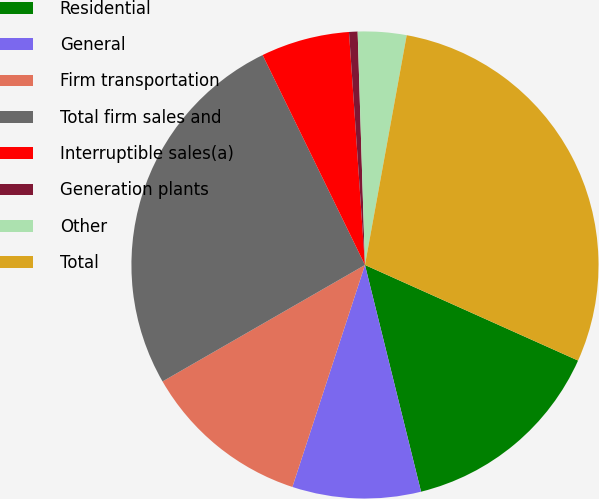Convert chart. <chart><loc_0><loc_0><loc_500><loc_500><pie_chart><fcel>Residential<fcel>General<fcel>Firm transportation<fcel>Total firm sales and<fcel>Interruptible sales(a)<fcel>Generation plants<fcel>Other<fcel>Total<nl><fcel>14.43%<fcel>8.89%<fcel>11.66%<fcel>26.09%<fcel>6.13%<fcel>0.59%<fcel>3.36%<fcel>28.85%<nl></chart> 